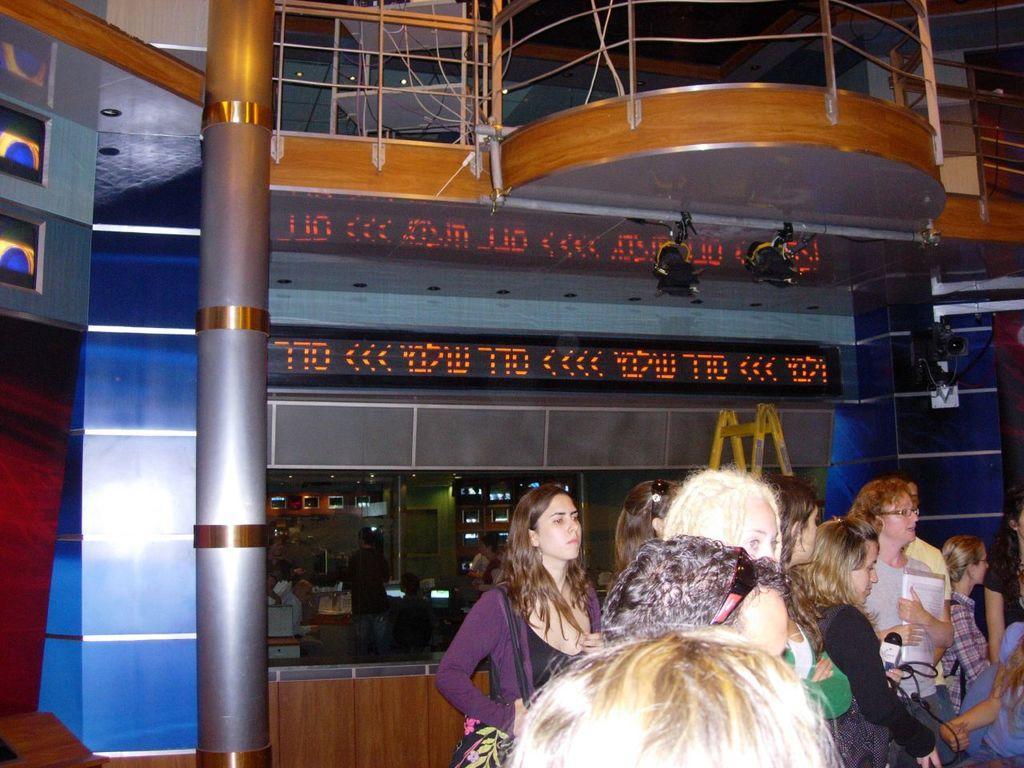Describe this image in one or two sentences. In this picture I can see people standing on the surface. I can see a person holding the microphone. I can see lcd screen. I can see the metal grill fence. 